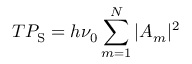Convert formula to latex. <formula><loc_0><loc_0><loc_500><loc_500>T P _ { S } = h \nu _ { 0 } \sum _ { m = 1 } ^ { N } | A _ { m } | ^ { 2 }</formula> 